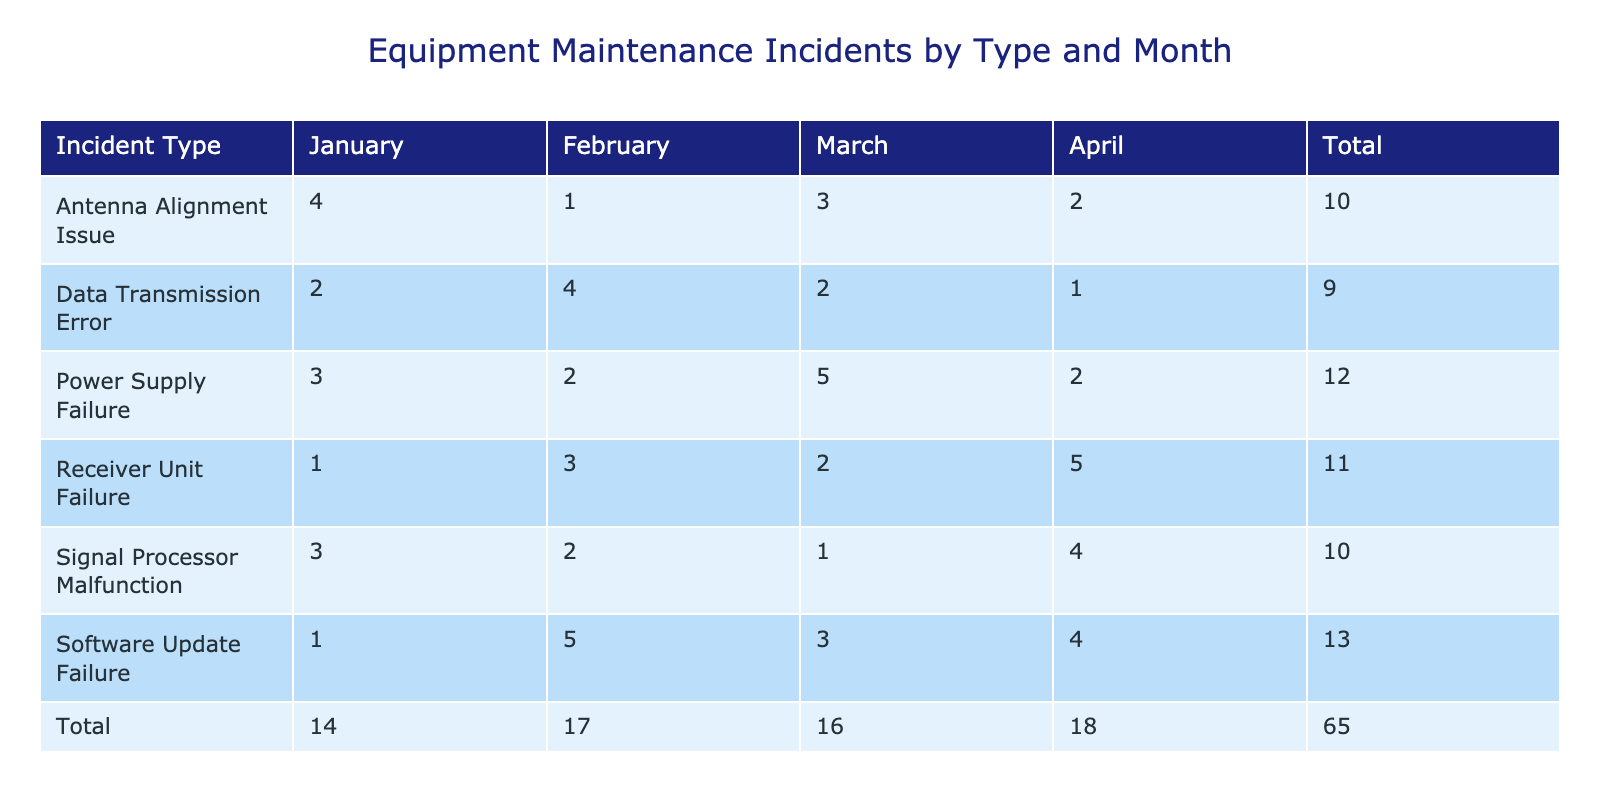what is the total number of incidents for signal processor malfunction? To find the total number of incidents for signal processor malfunction, we look at the row for this incident type and sum the counts across all months: 3 (January) + 2 (February) + 1 (March) + 4 (April) = 10
Answer: 10 which month had the highest number of receiver unit failure incidents? We check the column for Receiver Unit Failure and compare the numbers for each month: January (1), February (3), March (2), April (5). The maximum value is 5 in April, indicating that April had the highest incidents.
Answer: April how many total incidents were reported in January? To find the total incidents reported in January, we need to sum the counts for all incident types in that column: 3 (Signal Processor Malfunction) + 1 (Receiver Unit Failure) + 4 (Antenna Alignment Issue) + 2 (Data Transmission Error) + 3 (Power Supply Failure) + 1 (Software Update Failure) = 14
Answer: 14 did the antenna alignment issue have more incidents than the software update failure across all months? First, we summarize the total counts for each: Antenna Alignment Issue = 4 (January) + 1 (February) + 3 (March) + 2 (April) = 10; Software Update Failure = 1 (January) + 5 (February) + 3 (March) + 4 (April) = 13. Since 10 < 13, the statement is false.
Answer: No what is the average number of incidents for power supply failure across the four months? To find the average for power supply failure, we sum the incidents: 3 (January) + 2 (February) + 5 (March) + 2 (April) = 12. Then, divide this total by the number of months, which is 4. So, the average is 12 / 4 = 3.
Answer: 3 which incident type had the lowest total number of incidents? We need to calculate the total incidents for each incident type: Signal Processor Malfunction (10), Receiver Unit Failure (11), Antenna Alignment Issue (10), Data Transmission Error (9), Power Supply Failure (12), Software Update Failure (13). The lowest total is for Data Transmission Error with 9 incidents.
Answer: Data Transmission Error in which month was the software update failure reported most frequently? We refer to the Software Update Failure row: January (1), February (5), March (3), and April (4). The highest count is in February, indicating that it was the most frequent month for this incident.
Answer: February how many incidents were reported in total for the antenna alignment issue in the first quarter? The first quarter includes January, February, and March. Summing the incidents for this type in those months gives: 4 (January) + 1 (February) + 3 (March) = 8. So, there were 8 incidents reported in total for the antenna alignment issue in the first quarter.
Answer: 8 is there a month where all incident types reported incidents equal to or greater than 5? By examining the incident counts for each month, we find: January: 3+1+4+2+3+1=14, February: 2+3+1+4+2+5=17, March: 1+2+3+2+5+3=16, April: 4+5+2+1+2+4=18. None of the months had all incident types reporting at least 5 incidents.
Answer: No 